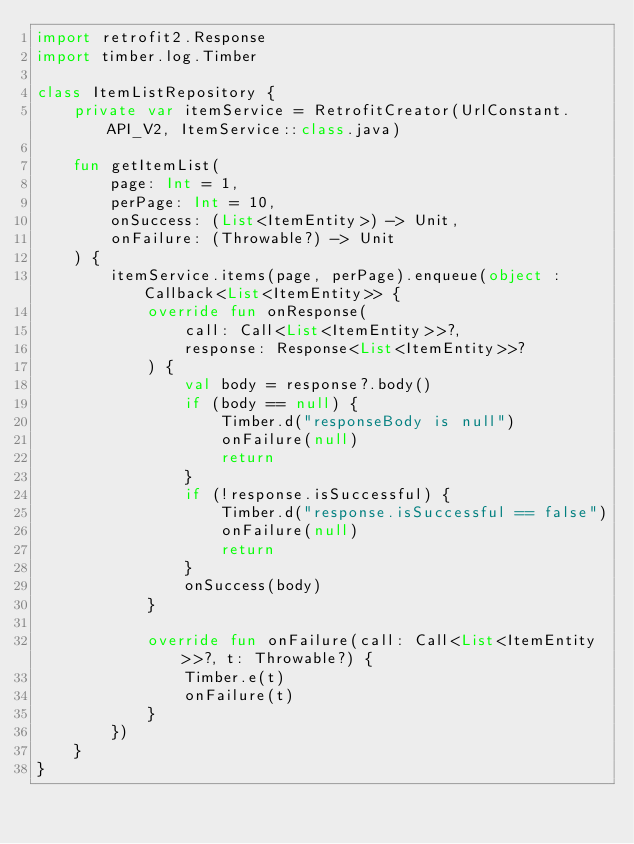Convert code to text. <code><loc_0><loc_0><loc_500><loc_500><_Kotlin_>import retrofit2.Response
import timber.log.Timber

class ItemListRepository {
    private var itemService = RetrofitCreator(UrlConstant.API_V2, ItemService::class.java)

    fun getItemList(
        page: Int = 1,
        perPage: Int = 10,
        onSuccess: (List<ItemEntity>) -> Unit,
        onFailure: (Throwable?) -> Unit
    ) {
        itemService.items(page, perPage).enqueue(object : Callback<List<ItemEntity>> {
            override fun onResponse(
                call: Call<List<ItemEntity>>?,
                response: Response<List<ItemEntity>>?
            ) {
                val body = response?.body()
                if (body == null) {
                    Timber.d("responseBody is null")
                    onFailure(null)
                    return
                }
                if (!response.isSuccessful) {
                    Timber.d("response.isSuccessful == false")
                    onFailure(null)
                    return
                }
                onSuccess(body)
            }

            override fun onFailure(call: Call<List<ItemEntity>>?, t: Throwable?) {
                Timber.e(t)
                onFailure(t)
            }
        })
    }
}</code> 